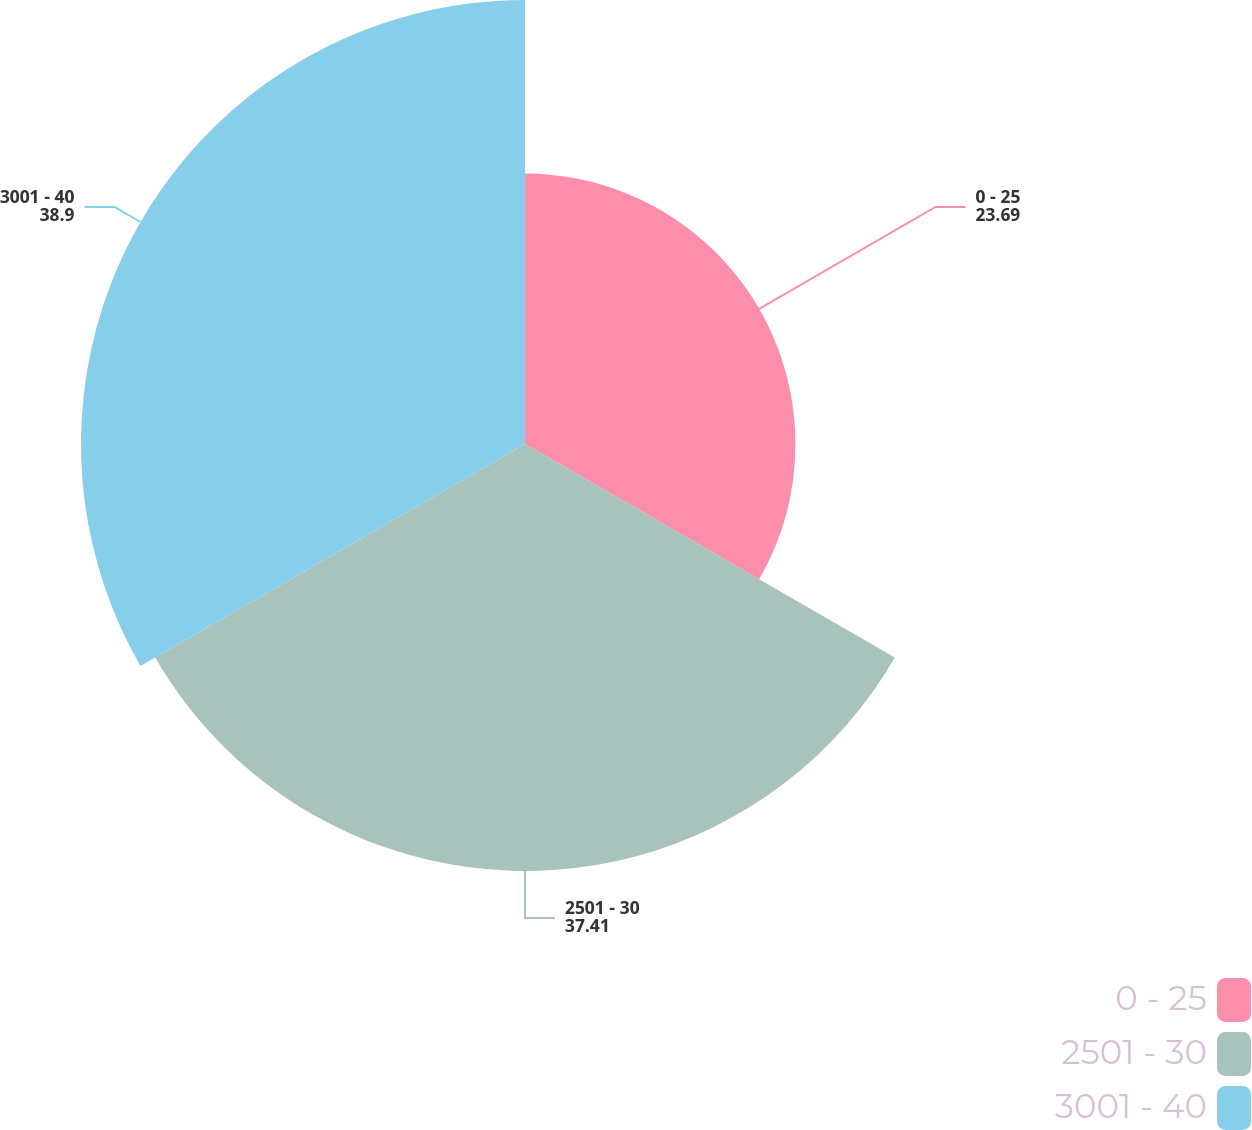<chart> <loc_0><loc_0><loc_500><loc_500><pie_chart><fcel>0 - 25<fcel>2501 - 30<fcel>3001 - 40<nl><fcel>23.69%<fcel>37.41%<fcel>38.9%<nl></chart> 